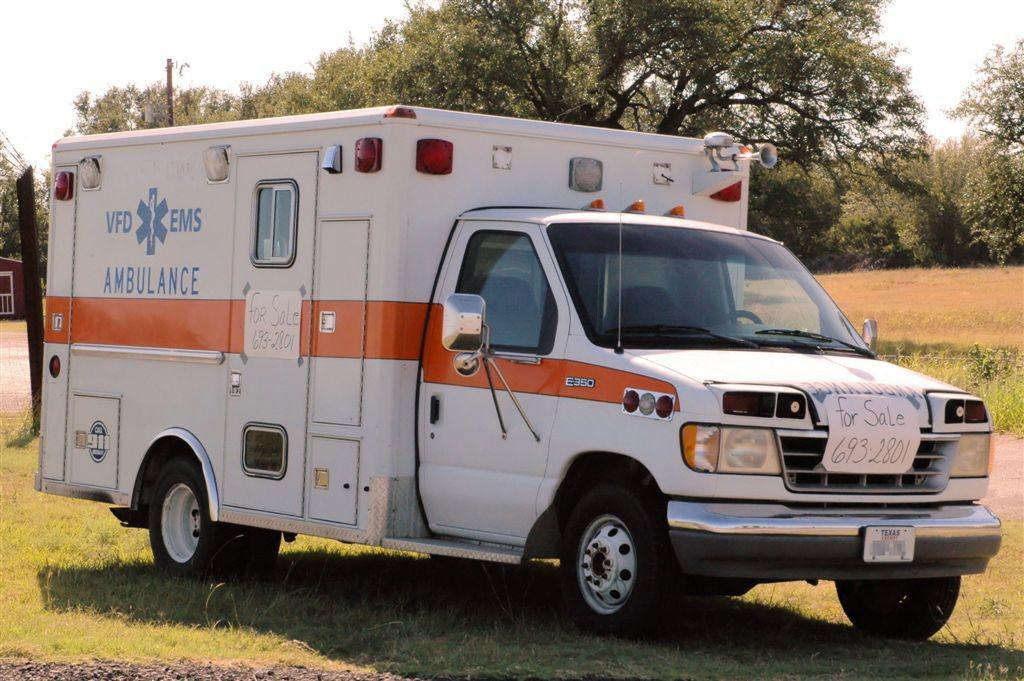<image>
Render a clear and concise summary of the photo. An ambulance is parked on a grass field. 